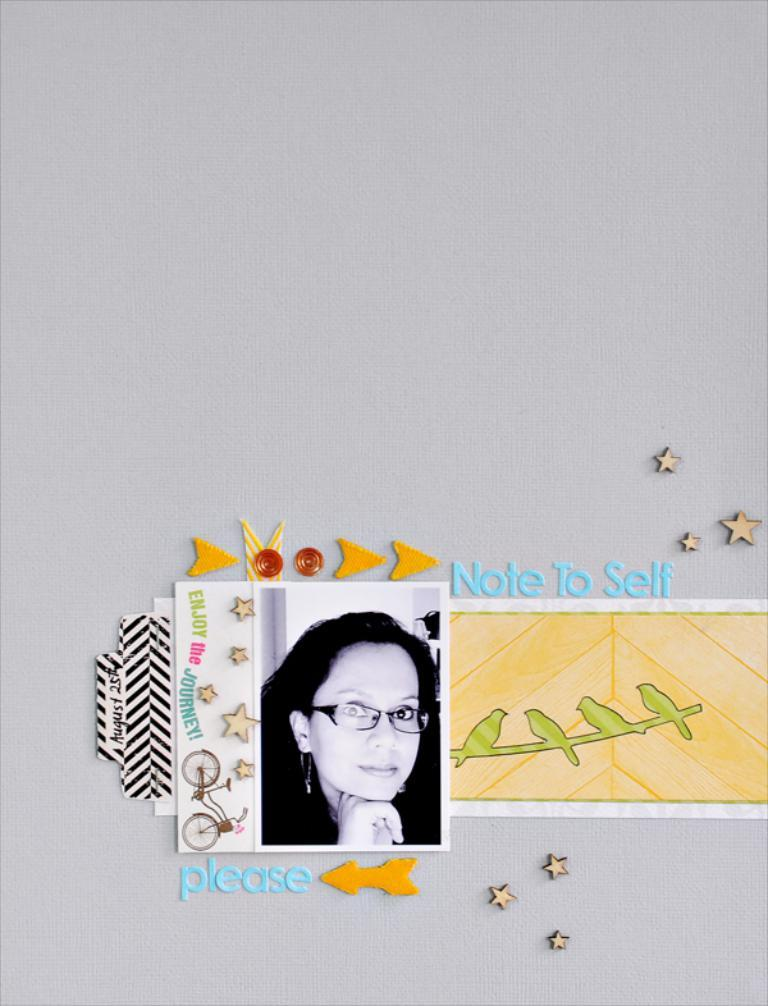What can be seen on the posts in the image? There are posts with images and text in the image. What type of objects are present in the image? There are crafted objects in the image. What color is the background of the image? The background of the image is white. How many sisters are depicted in the image? There are no sisters present in the image; it features posts with images and text, as well as crafted objects. What is the purpose of the mist in the image? There is no mist present in the image; it has a white background. 